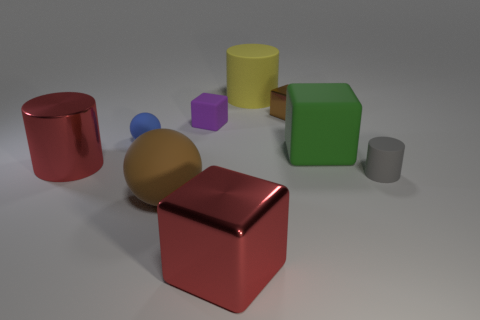What size is the gray matte thing that is to the right of the red metal object that is in front of the large matte ball?
Your answer should be compact. Small. Is there a red matte thing that has the same size as the gray cylinder?
Your answer should be very brief. No. There is a cylinder that is made of the same material as the big red cube; what color is it?
Provide a short and direct response. Red. Is the number of big red matte spheres less than the number of big rubber cylinders?
Your answer should be compact. Yes. What is the big object that is left of the big rubber cylinder and to the right of the purple matte block made of?
Offer a terse response. Metal. There is a small gray rubber cylinder that is behind the big shiny block; are there any matte objects behind it?
Your response must be concise. Yes. How many tiny blocks are the same color as the big rubber sphere?
Ensure brevity in your answer.  1. There is a big object that is the same color as the large shiny cylinder; what is it made of?
Offer a terse response. Metal. Do the blue object and the big brown object have the same material?
Your answer should be very brief. Yes. Are there any gray rubber things behind the tiny matte cylinder?
Offer a very short reply. No. 